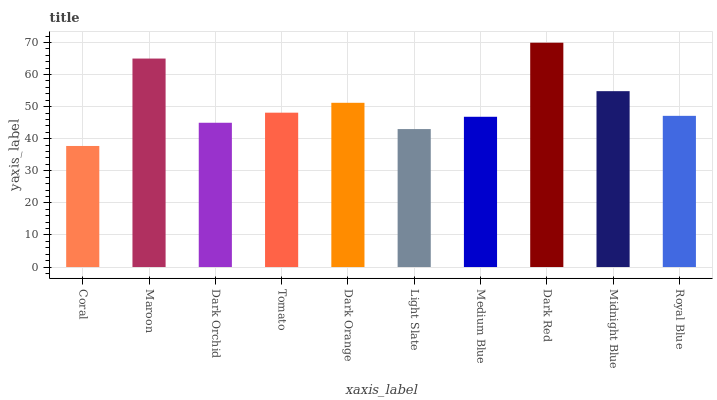Is Coral the minimum?
Answer yes or no. Yes. Is Dark Red the maximum?
Answer yes or no. Yes. Is Maroon the minimum?
Answer yes or no. No. Is Maroon the maximum?
Answer yes or no. No. Is Maroon greater than Coral?
Answer yes or no. Yes. Is Coral less than Maroon?
Answer yes or no. Yes. Is Coral greater than Maroon?
Answer yes or no. No. Is Maroon less than Coral?
Answer yes or no. No. Is Tomato the high median?
Answer yes or no. Yes. Is Royal Blue the low median?
Answer yes or no. Yes. Is Dark Orchid the high median?
Answer yes or no. No. Is Light Slate the low median?
Answer yes or no. No. 